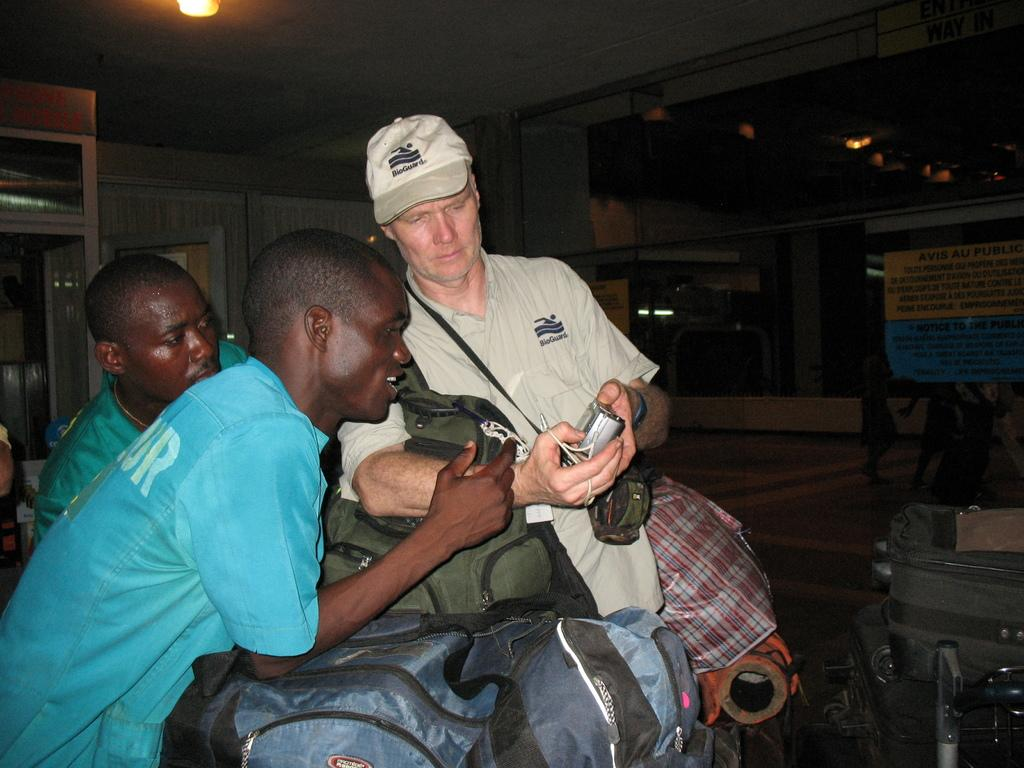What can be seen in the image that provides illumination? There are lights in the image. What type of objects are present in the image that can be used for displaying information or advertisements? There are boards in the image. Who is present in the image? There are people in the image. What items can be seen that might be used for carrying belongings? There are bags in the image. What surface is visible in the image? There is a floor visible in the image. What else can be seen in the image besides the people and objects mentioned? There are objects in the image. What are the people in the image doing? People are staring at a camera. Can you describe the appearance of one of the individuals in the image? There is a man wearing a cap in the image. What is the man holding in the image? The man is holding a camera. Where is the aunt sitting in the image? There is no mention of an aunt in the image. What is the limit of the objects in the image? There is no limit mentioned for the objects in the image. On which side of the image are the people standing? The image does not specify a particular side for the people to stand on. 